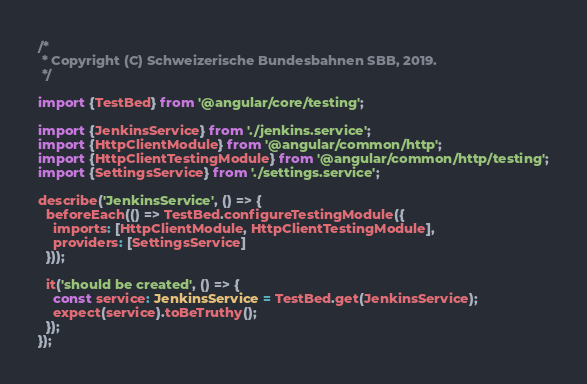<code> <loc_0><loc_0><loc_500><loc_500><_TypeScript_>/*
 * Copyright (C) Schweizerische Bundesbahnen SBB, 2019.
 */

import {TestBed} from '@angular/core/testing';

import {JenkinsService} from './jenkins.service';
import {HttpClientModule} from '@angular/common/http';
import {HttpClientTestingModule} from '@angular/common/http/testing';
import {SettingsService} from './settings.service';

describe('JenkinsService', () => {
  beforeEach(() => TestBed.configureTestingModule({
    imports: [HttpClientModule, HttpClientTestingModule],
    providers: [SettingsService]
  }));

  it('should be created', () => {
    const service: JenkinsService = TestBed.get(JenkinsService);
    expect(service).toBeTruthy();
  });
});
</code> 